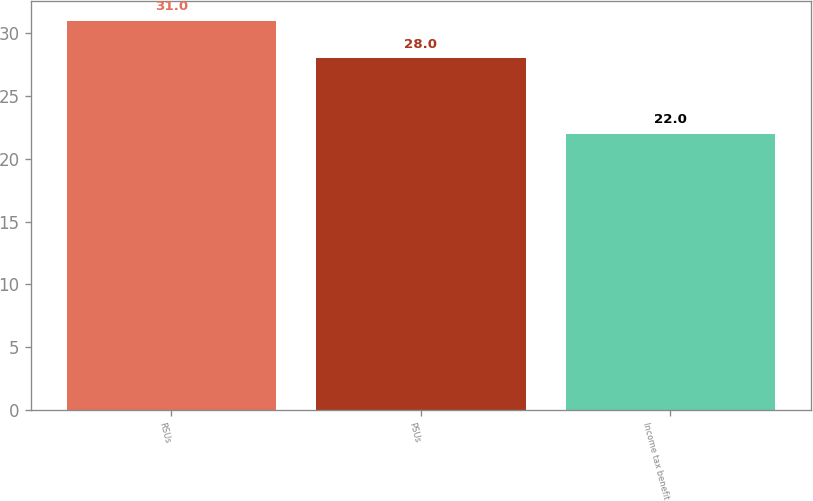Convert chart. <chart><loc_0><loc_0><loc_500><loc_500><bar_chart><fcel>RSUs<fcel>PSUs<fcel>Income tax benefit<nl><fcel>31<fcel>28<fcel>22<nl></chart> 